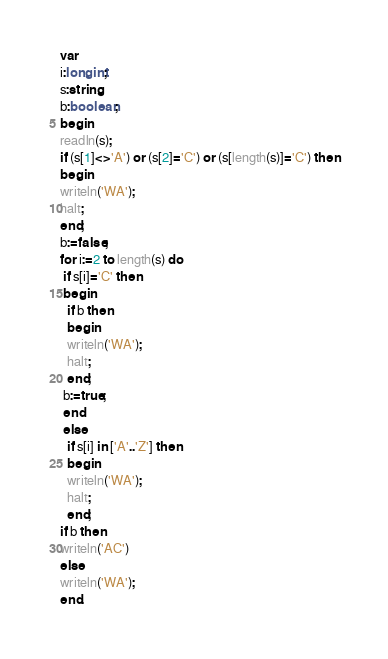Convert code to text. <code><loc_0><loc_0><loc_500><loc_500><_Pascal_>var
i:longint;
s:string;
b:boolean;
begin
readln(s);
if (s[1]<>'A') or (s[2]='C') or (s[length(s)]='C') then
begin
writeln('WA');
halt;
end;
b:=false;
for i:=2 to length(s) do
 if s[i]='C' then
 begin
  if b then
  begin
  writeln('WA');
  halt;
  end;
 b:=true;
 end
 else
  if s[i] in ['A'..'Z'] then
  begin
  writeln('WA');
  halt;
  end;
if b then
writeln('AC')
else
writeln('WA');
end.
</code> 